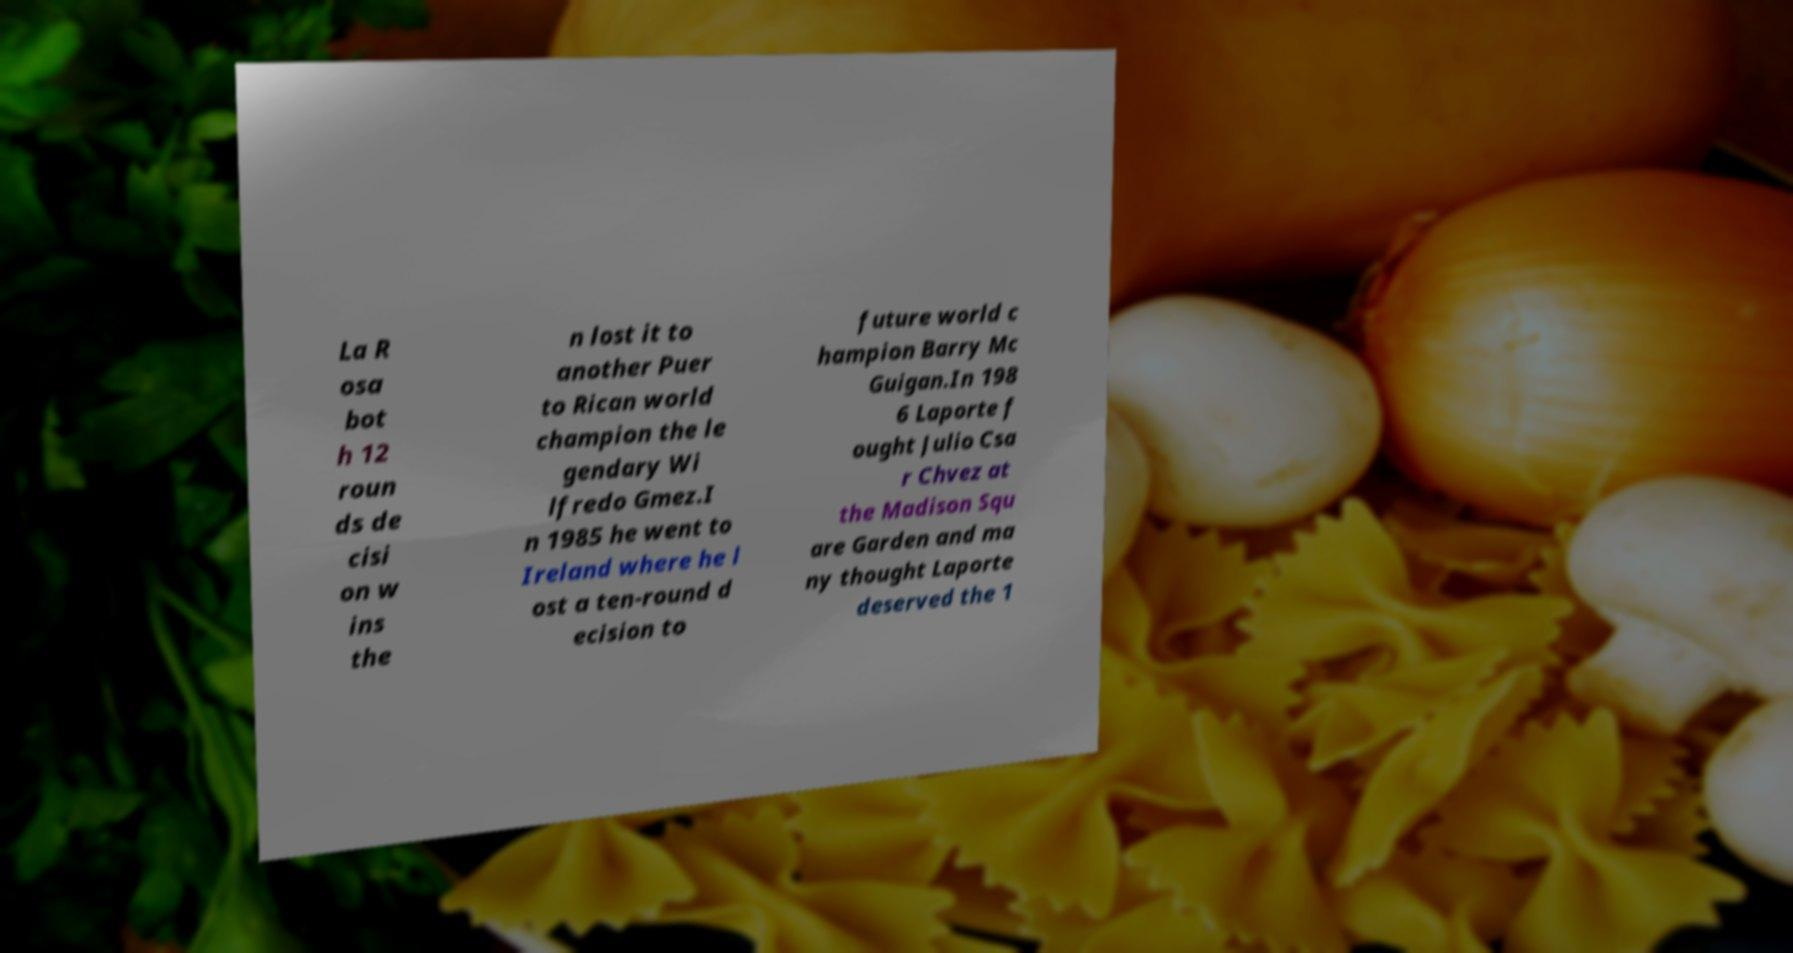For documentation purposes, I need the text within this image transcribed. Could you provide that? La R osa bot h 12 roun ds de cisi on w ins the n lost it to another Puer to Rican world champion the le gendary Wi lfredo Gmez.I n 1985 he went to Ireland where he l ost a ten-round d ecision to future world c hampion Barry Mc Guigan.In 198 6 Laporte f ought Julio Csa r Chvez at the Madison Squ are Garden and ma ny thought Laporte deserved the 1 